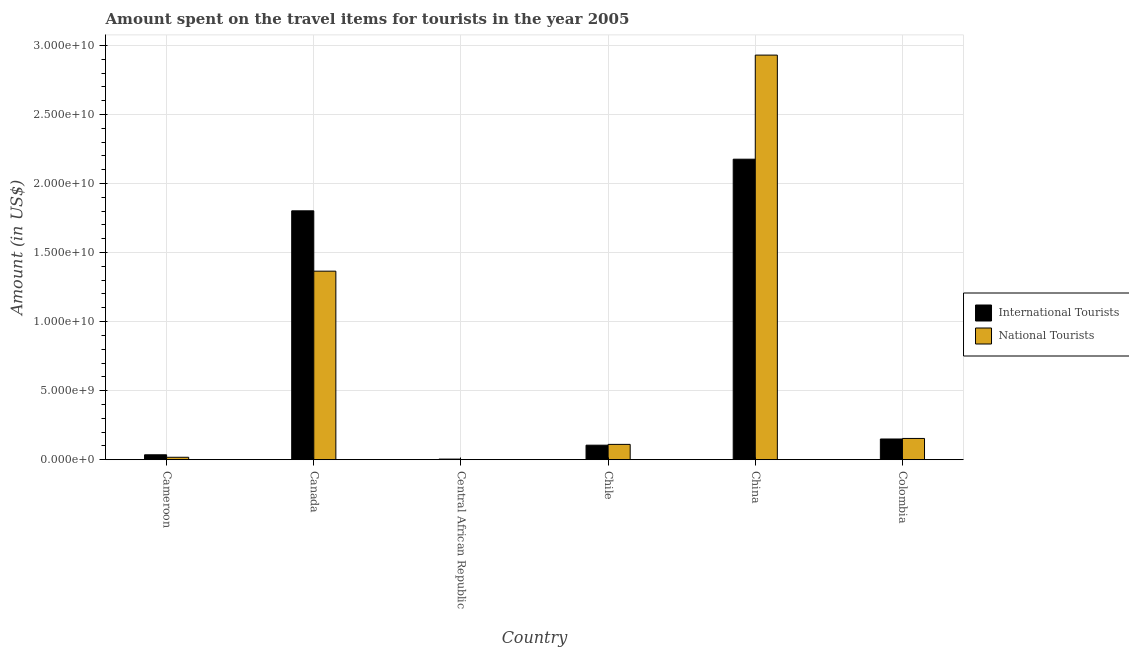How many groups of bars are there?
Keep it short and to the point. 6. Are the number of bars per tick equal to the number of legend labels?
Provide a short and direct response. Yes. Are the number of bars on each tick of the X-axis equal?
Offer a very short reply. Yes. Across all countries, what is the maximum amount spent on travel items of national tourists?
Offer a terse response. 2.93e+1. Across all countries, what is the minimum amount spent on travel items of international tourists?
Give a very brief answer. 4.40e+07. In which country was the amount spent on travel items of national tourists minimum?
Your answer should be very brief. Central African Republic. What is the total amount spent on travel items of national tourists in the graph?
Your response must be concise. 4.58e+1. What is the difference between the amount spent on travel items of national tourists in Central African Republic and that in Chile?
Provide a short and direct response. -1.10e+09. What is the difference between the amount spent on travel items of international tourists in Chile and the amount spent on travel items of national tourists in Cameroon?
Make the answer very short. 8.76e+08. What is the average amount spent on travel items of international tourists per country?
Provide a succinct answer. 7.12e+09. What is the difference between the amount spent on travel items of international tourists and amount spent on travel items of national tourists in Canada?
Make the answer very short. 4.37e+09. In how many countries, is the amount spent on travel items of international tourists greater than 13000000000 US$?
Make the answer very short. 2. What is the ratio of the amount spent on travel items of national tourists in Canada to that in China?
Your response must be concise. 0.47. What is the difference between the highest and the second highest amount spent on travel items of international tourists?
Your answer should be very brief. 3.74e+09. What is the difference between the highest and the lowest amount spent on travel items of national tourists?
Your response must be concise. 2.93e+1. In how many countries, is the amount spent on travel items of national tourists greater than the average amount spent on travel items of national tourists taken over all countries?
Offer a terse response. 2. What does the 1st bar from the left in Cameroon represents?
Offer a very short reply. International Tourists. What does the 2nd bar from the right in Canada represents?
Your answer should be compact. International Tourists. How many countries are there in the graph?
Offer a very short reply. 6. Are the values on the major ticks of Y-axis written in scientific E-notation?
Your answer should be very brief. Yes. Does the graph contain any zero values?
Give a very brief answer. No. Where does the legend appear in the graph?
Keep it short and to the point. Center right. What is the title of the graph?
Offer a very short reply. Amount spent on the travel items for tourists in the year 2005. What is the Amount (in US$) in International Tourists in Cameroon?
Offer a very short reply. 3.55e+08. What is the Amount (in US$) in National Tourists in Cameroon?
Provide a short and direct response. 1.75e+08. What is the Amount (in US$) of International Tourists in Canada?
Give a very brief answer. 1.80e+1. What is the Amount (in US$) in National Tourists in Canada?
Offer a terse response. 1.37e+1. What is the Amount (in US$) of International Tourists in Central African Republic?
Your answer should be compact. 4.40e+07. What is the Amount (in US$) of National Tourists in Central African Republic?
Your response must be concise. 5.00e+06. What is the Amount (in US$) of International Tourists in Chile?
Your response must be concise. 1.05e+09. What is the Amount (in US$) in National Tourists in Chile?
Make the answer very short. 1.11e+09. What is the Amount (in US$) in International Tourists in China?
Keep it short and to the point. 2.18e+1. What is the Amount (in US$) of National Tourists in China?
Give a very brief answer. 2.93e+1. What is the Amount (in US$) in International Tourists in Colombia?
Offer a terse response. 1.50e+09. What is the Amount (in US$) of National Tourists in Colombia?
Make the answer very short. 1.54e+09. Across all countries, what is the maximum Amount (in US$) in International Tourists?
Your answer should be compact. 2.18e+1. Across all countries, what is the maximum Amount (in US$) of National Tourists?
Make the answer very short. 2.93e+1. Across all countries, what is the minimum Amount (in US$) of International Tourists?
Make the answer very short. 4.40e+07. Across all countries, what is the minimum Amount (in US$) in National Tourists?
Provide a short and direct response. 5.00e+06. What is the total Amount (in US$) in International Tourists in the graph?
Offer a very short reply. 4.27e+1. What is the total Amount (in US$) of National Tourists in the graph?
Ensure brevity in your answer.  4.58e+1. What is the difference between the Amount (in US$) in International Tourists in Cameroon and that in Canada?
Give a very brief answer. -1.77e+1. What is the difference between the Amount (in US$) in National Tourists in Cameroon and that in Canada?
Keep it short and to the point. -1.35e+1. What is the difference between the Amount (in US$) in International Tourists in Cameroon and that in Central African Republic?
Your answer should be very brief. 3.11e+08. What is the difference between the Amount (in US$) in National Tourists in Cameroon and that in Central African Republic?
Offer a terse response. 1.70e+08. What is the difference between the Amount (in US$) of International Tourists in Cameroon and that in Chile?
Ensure brevity in your answer.  -6.96e+08. What is the difference between the Amount (in US$) of National Tourists in Cameroon and that in Chile?
Provide a short and direct response. -9.34e+08. What is the difference between the Amount (in US$) in International Tourists in Cameroon and that in China?
Offer a very short reply. -2.14e+1. What is the difference between the Amount (in US$) of National Tourists in Cameroon and that in China?
Your answer should be very brief. -2.91e+1. What is the difference between the Amount (in US$) of International Tourists in Cameroon and that in Colombia?
Provide a succinct answer. -1.14e+09. What is the difference between the Amount (in US$) of National Tourists in Cameroon and that in Colombia?
Your answer should be very brief. -1.36e+09. What is the difference between the Amount (in US$) in International Tourists in Canada and that in Central African Republic?
Provide a succinct answer. 1.80e+1. What is the difference between the Amount (in US$) of National Tourists in Canada and that in Central African Republic?
Your answer should be very brief. 1.36e+1. What is the difference between the Amount (in US$) in International Tourists in Canada and that in Chile?
Your response must be concise. 1.70e+1. What is the difference between the Amount (in US$) of National Tourists in Canada and that in Chile?
Your answer should be compact. 1.25e+1. What is the difference between the Amount (in US$) in International Tourists in Canada and that in China?
Ensure brevity in your answer.  -3.74e+09. What is the difference between the Amount (in US$) of National Tourists in Canada and that in China?
Make the answer very short. -1.56e+1. What is the difference between the Amount (in US$) in International Tourists in Canada and that in Colombia?
Give a very brief answer. 1.65e+1. What is the difference between the Amount (in US$) of National Tourists in Canada and that in Colombia?
Your answer should be very brief. 1.21e+1. What is the difference between the Amount (in US$) of International Tourists in Central African Republic and that in Chile?
Your answer should be very brief. -1.01e+09. What is the difference between the Amount (in US$) in National Tourists in Central African Republic and that in Chile?
Ensure brevity in your answer.  -1.10e+09. What is the difference between the Amount (in US$) in International Tourists in Central African Republic and that in China?
Your answer should be very brief. -2.17e+1. What is the difference between the Amount (in US$) in National Tourists in Central African Republic and that in China?
Your answer should be very brief. -2.93e+1. What is the difference between the Amount (in US$) of International Tourists in Central African Republic and that in Colombia?
Ensure brevity in your answer.  -1.46e+09. What is the difference between the Amount (in US$) in National Tourists in Central African Republic and that in Colombia?
Keep it short and to the point. -1.53e+09. What is the difference between the Amount (in US$) in International Tourists in Chile and that in China?
Your answer should be compact. -2.07e+1. What is the difference between the Amount (in US$) of National Tourists in Chile and that in China?
Ensure brevity in your answer.  -2.82e+1. What is the difference between the Amount (in US$) of International Tourists in Chile and that in Colombia?
Your response must be concise. -4.48e+08. What is the difference between the Amount (in US$) in National Tourists in Chile and that in Colombia?
Provide a succinct answer. -4.30e+08. What is the difference between the Amount (in US$) of International Tourists in China and that in Colombia?
Your response must be concise. 2.03e+1. What is the difference between the Amount (in US$) of National Tourists in China and that in Colombia?
Keep it short and to the point. 2.78e+1. What is the difference between the Amount (in US$) in International Tourists in Cameroon and the Amount (in US$) in National Tourists in Canada?
Keep it short and to the point. -1.33e+1. What is the difference between the Amount (in US$) of International Tourists in Cameroon and the Amount (in US$) of National Tourists in Central African Republic?
Give a very brief answer. 3.50e+08. What is the difference between the Amount (in US$) in International Tourists in Cameroon and the Amount (in US$) in National Tourists in Chile?
Your answer should be compact. -7.54e+08. What is the difference between the Amount (in US$) of International Tourists in Cameroon and the Amount (in US$) of National Tourists in China?
Make the answer very short. -2.89e+1. What is the difference between the Amount (in US$) in International Tourists in Cameroon and the Amount (in US$) in National Tourists in Colombia?
Provide a short and direct response. -1.18e+09. What is the difference between the Amount (in US$) of International Tourists in Canada and the Amount (in US$) of National Tourists in Central African Republic?
Provide a succinct answer. 1.80e+1. What is the difference between the Amount (in US$) of International Tourists in Canada and the Amount (in US$) of National Tourists in Chile?
Offer a very short reply. 1.69e+1. What is the difference between the Amount (in US$) in International Tourists in Canada and the Amount (in US$) in National Tourists in China?
Provide a succinct answer. -1.13e+1. What is the difference between the Amount (in US$) of International Tourists in Canada and the Amount (in US$) of National Tourists in Colombia?
Your answer should be compact. 1.65e+1. What is the difference between the Amount (in US$) of International Tourists in Central African Republic and the Amount (in US$) of National Tourists in Chile?
Your response must be concise. -1.06e+09. What is the difference between the Amount (in US$) in International Tourists in Central African Republic and the Amount (in US$) in National Tourists in China?
Offer a terse response. -2.93e+1. What is the difference between the Amount (in US$) of International Tourists in Central African Republic and the Amount (in US$) of National Tourists in Colombia?
Your response must be concise. -1.50e+09. What is the difference between the Amount (in US$) in International Tourists in Chile and the Amount (in US$) in National Tourists in China?
Provide a succinct answer. -2.82e+1. What is the difference between the Amount (in US$) in International Tourists in Chile and the Amount (in US$) in National Tourists in Colombia?
Ensure brevity in your answer.  -4.88e+08. What is the difference between the Amount (in US$) in International Tourists in China and the Amount (in US$) in National Tourists in Colombia?
Offer a very short reply. 2.02e+1. What is the average Amount (in US$) of International Tourists per country?
Keep it short and to the point. 7.12e+09. What is the average Amount (in US$) in National Tourists per country?
Keep it short and to the point. 7.63e+09. What is the difference between the Amount (in US$) of International Tourists and Amount (in US$) of National Tourists in Cameroon?
Your answer should be compact. 1.80e+08. What is the difference between the Amount (in US$) of International Tourists and Amount (in US$) of National Tourists in Canada?
Provide a succinct answer. 4.37e+09. What is the difference between the Amount (in US$) in International Tourists and Amount (in US$) in National Tourists in Central African Republic?
Ensure brevity in your answer.  3.90e+07. What is the difference between the Amount (in US$) in International Tourists and Amount (in US$) in National Tourists in Chile?
Give a very brief answer. -5.80e+07. What is the difference between the Amount (in US$) in International Tourists and Amount (in US$) in National Tourists in China?
Ensure brevity in your answer.  -7.54e+09. What is the difference between the Amount (in US$) of International Tourists and Amount (in US$) of National Tourists in Colombia?
Your response must be concise. -4.00e+07. What is the ratio of the Amount (in US$) of International Tourists in Cameroon to that in Canada?
Ensure brevity in your answer.  0.02. What is the ratio of the Amount (in US$) of National Tourists in Cameroon to that in Canada?
Provide a short and direct response. 0.01. What is the ratio of the Amount (in US$) of International Tourists in Cameroon to that in Central African Republic?
Make the answer very short. 8.07. What is the ratio of the Amount (in US$) of International Tourists in Cameroon to that in Chile?
Offer a very short reply. 0.34. What is the ratio of the Amount (in US$) of National Tourists in Cameroon to that in Chile?
Your answer should be compact. 0.16. What is the ratio of the Amount (in US$) of International Tourists in Cameroon to that in China?
Offer a very short reply. 0.02. What is the ratio of the Amount (in US$) in National Tourists in Cameroon to that in China?
Your response must be concise. 0.01. What is the ratio of the Amount (in US$) in International Tourists in Cameroon to that in Colombia?
Provide a short and direct response. 0.24. What is the ratio of the Amount (in US$) in National Tourists in Cameroon to that in Colombia?
Provide a succinct answer. 0.11. What is the ratio of the Amount (in US$) in International Tourists in Canada to that in Central African Republic?
Ensure brevity in your answer.  409.57. What is the ratio of the Amount (in US$) in National Tourists in Canada to that in Central African Republic?
Offer a very short reply. 2730.2. What is the ratio of the Amount (in US$) of International Tourists in Canada to that in Chile?
Offer a terse response. 17.15. What is the ratio of the Amount (in US$) in National Tourists in Canada to that in Chile?
Give a very brief answer. 12.31. What is the ratio of the Amount (in US$) in International Tourists in Canada to that in China?
Provide a short and direct response. 0.83. What is the ratio of the Amount (in US$) of National Tourists in Canada to that in China?
Give a very brief answer. 0.47. What is the ratio of the Amount (in US$) in International Tourists in Canada to that in Colombia?
Provide a succinct answer. 12.02. What is the ratio of the Amount (in US$) of National Tourists in Canada to that in Colombia?
Offer a terse response. 8.87. What is the ratio of the Amount (in US$) in International Tourists in Central African Republic to that in Chile?
Offer a very short reply. 0.04. What is the ratio of the Amount (in US$) of National Tourists in Central African Republic to that in Chile?
Keep it short and to the point. 0. What is the ratio of the Amount (in US$) of International Tourists in Central African Republic to that in China?
Make the answer very short. 0. What is the ratio of the Amount (in US$) in International Tourists in Central African Republic to that in Colombia?
Offer a very short reply. 0.03. What is the ratio of the Amount (in US$) in National Tourists in Central African Republic to that in Colombia?
Ensure brevity in your answer.  0. What is the ratio of the Amount (in US$) in International Tourists in Chile to that in China?
Give a very brief answer. 0.05. What is the ratio of the Amount (in US$) of National Tourists in Chile to that in China?
Offer a terse response. 0.04. What is the ratio of the Amount (in US$) of International Tourists in Chile to that in Colombia?
Your response must be concise. 0.7. What is the ratio of the Amount (in US$) of National Tourists in Chile to that in Colombia?
Keep it short and to the point. 0.72. What is the ratio of the Amount (in US$) of International Tourists in China to that in Colombia?
Keep it short and to the point. 14.52. What is the ratio of the Amount (in US$) in National Tourists in China to that in Colombia?
Give a very brief answer. 19.04. What is the difference between the highest and the second highest Amount (in US$) in International Tourists?
Provide a short and direct response. 3.74e+09. What is the difference between the highest and the second highest Amount (in US$) of National Tourists?
Offer a very short reply. 1.56e+1. What is the difference between the highest and the lowest Amount (in US$) of International Tourists?
Ensure brevity in your answer.  2.17e+1. What is the difference between the highest and the lowest Amount (in US$) of National Tourists?
Keep it short and to the point. 2.93e+1. 